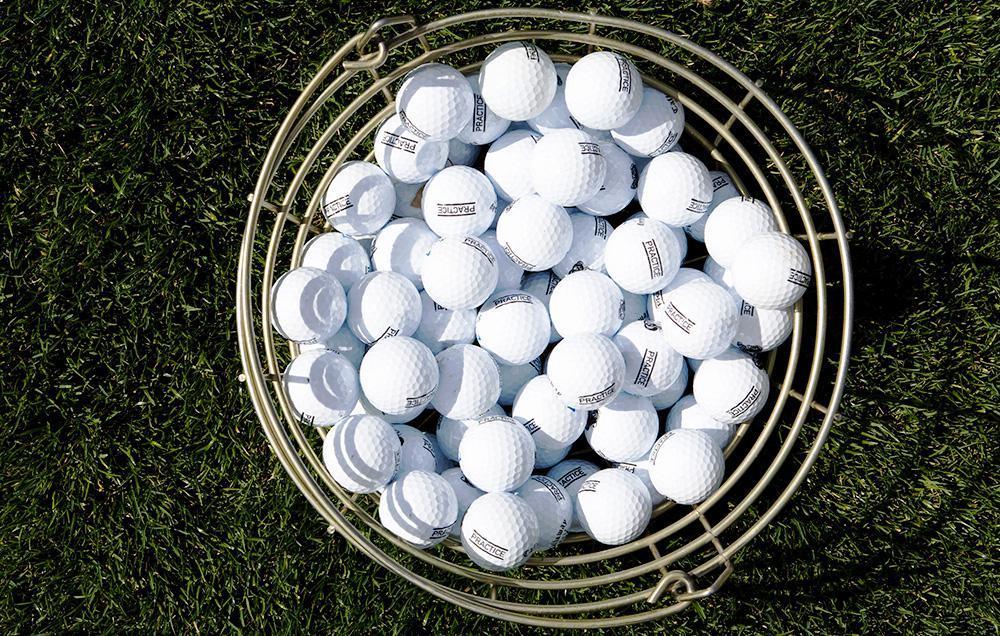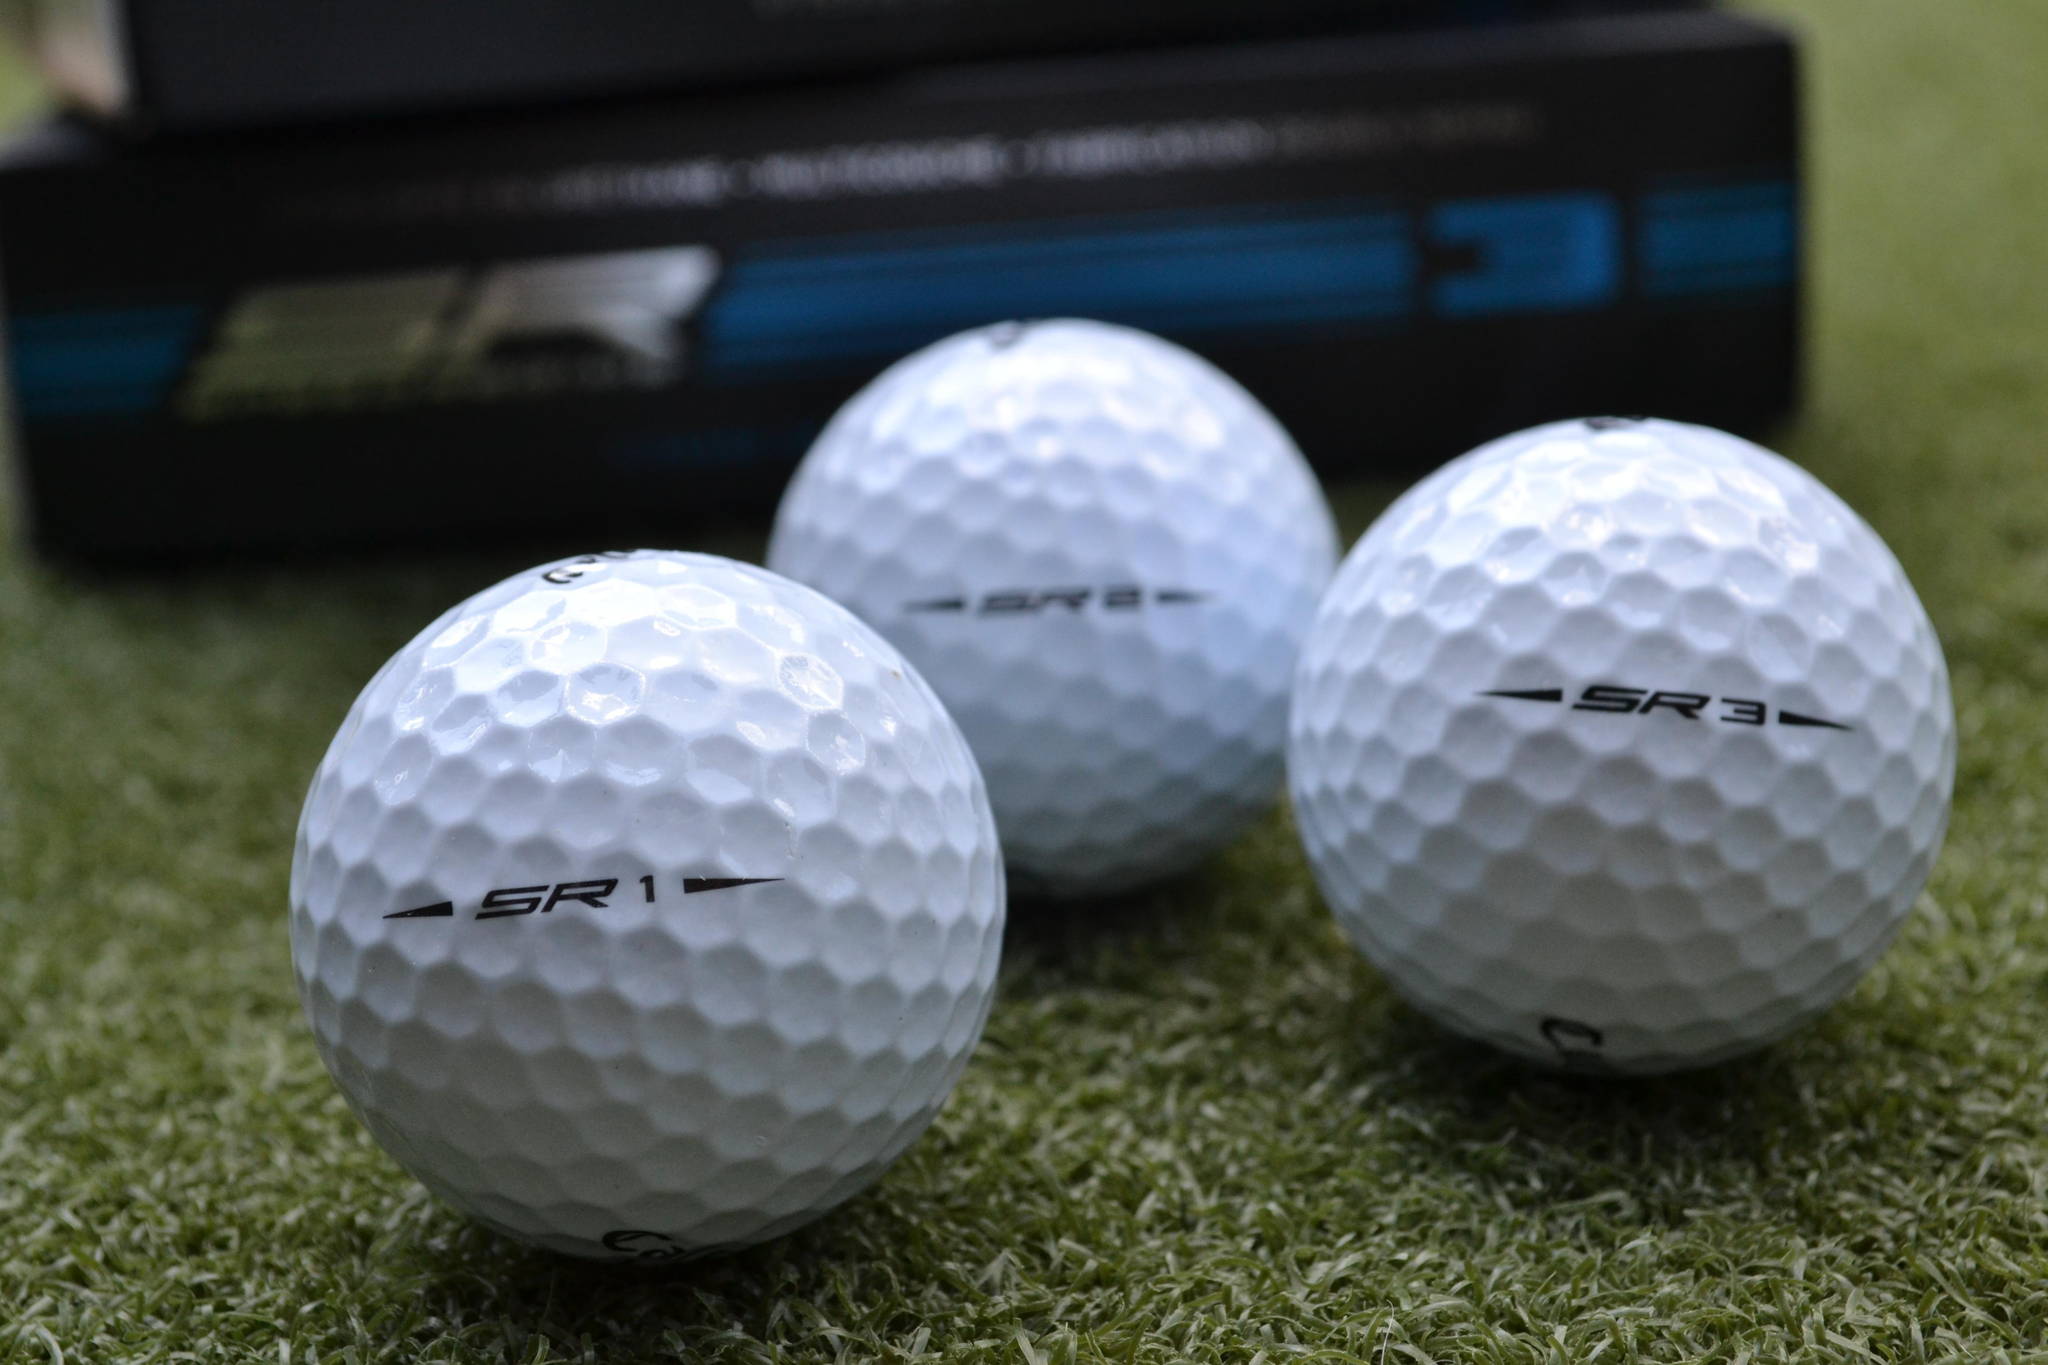The first image is the image on the left, the second image is the image on the right. Assess this claim about the two images: "There are two balls sitting directly on the grass.". Correct or not? Answer yes or no. No. The first image is the image on the left, the second image is the image on the right. Evaluate the accuracy of this statement regarding the images: "Each image contains only one actual, round golf ball.". Is it true? Answer yes or no. No. 